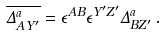<formula> <loc_0><loc_0><loc_500><loc_500>\overline { { { \Delta _ { A Y ^ { \prime } } ^ { a } } } } = \epsilon ^ { A B } \epsilon ^ { Y ^ { \prime } Z ^ { \prime } } \Delta _ { B Z ^ { \prime } } ^ { a } \, .</formula> 